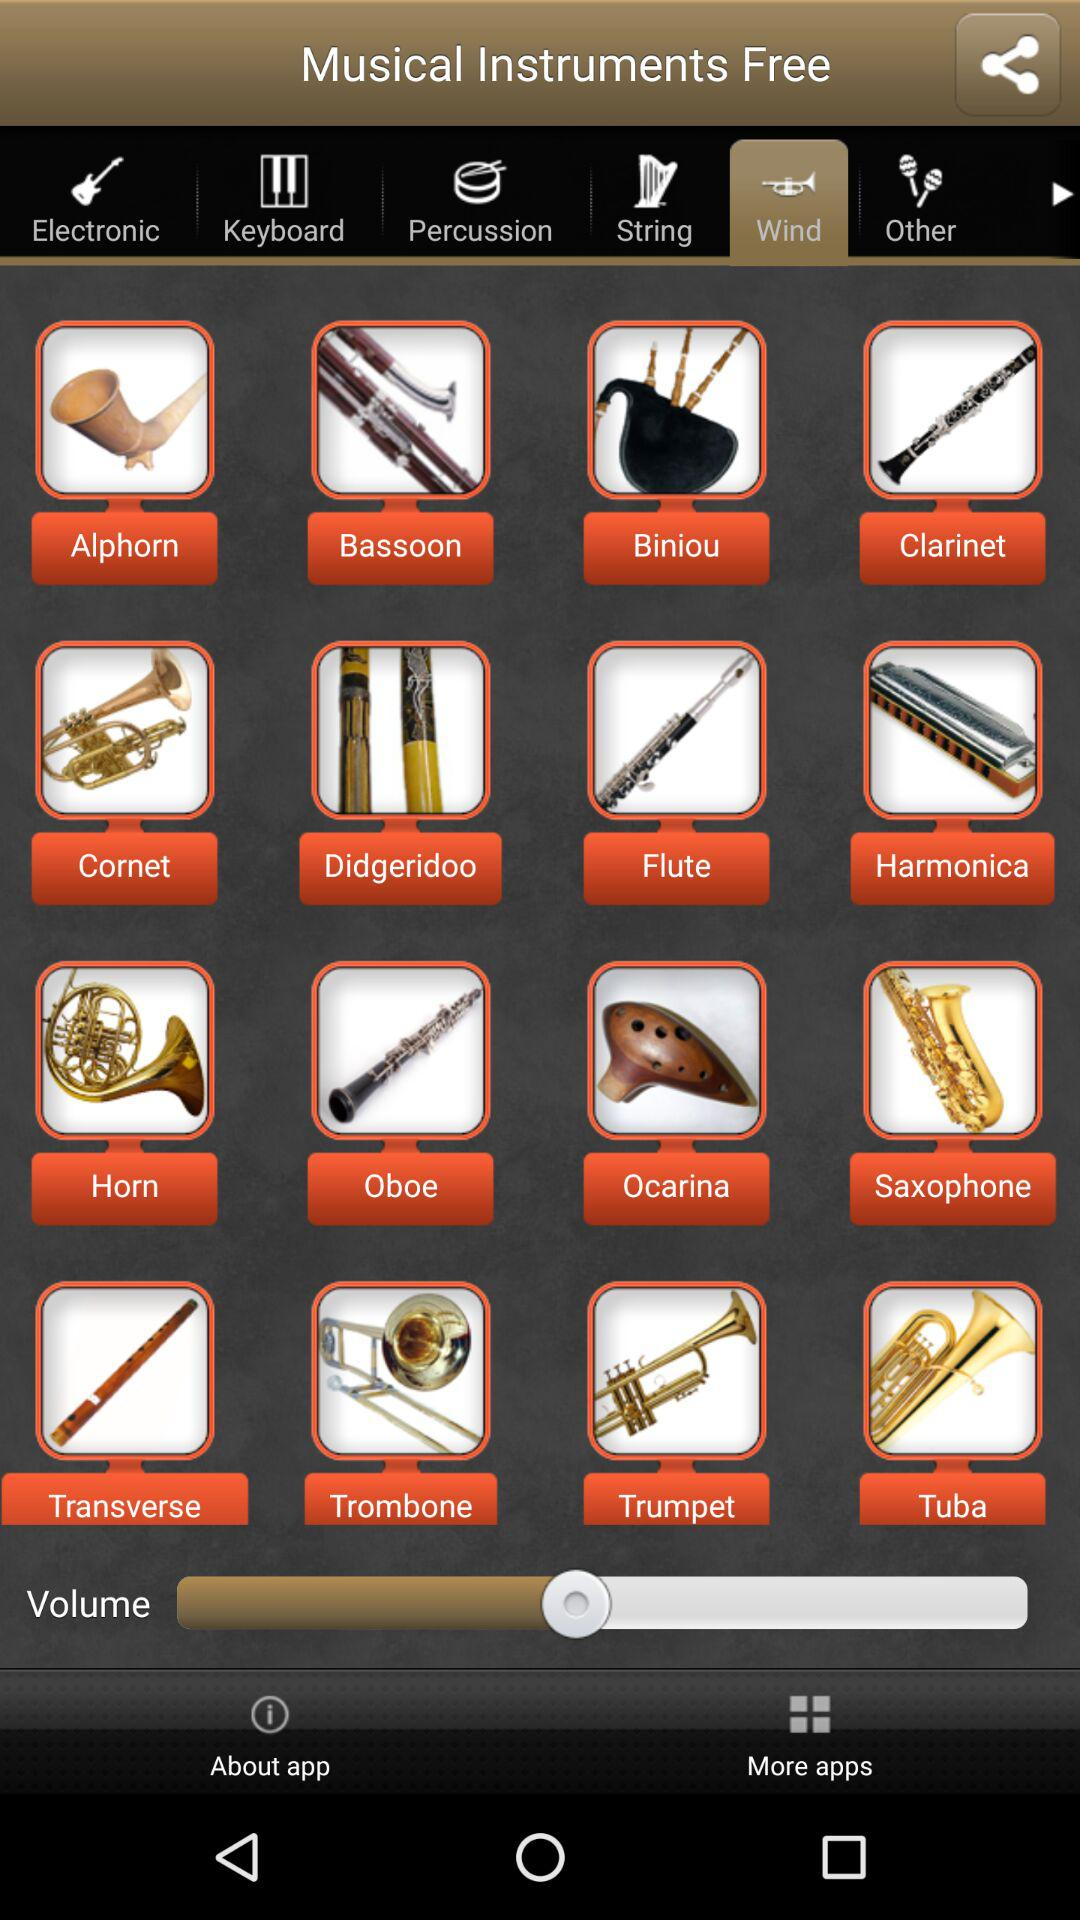What is the selected tab? The selected tab is "Wind". 